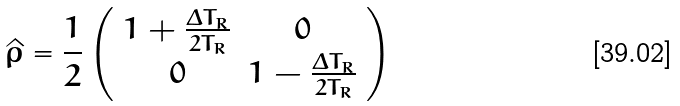<formula> <loc_0><loc_0><loc_500><loc_500>\hat { \rho } = \frac { 1 } { 2 } \left ( \begin{array} { c c } 1 + \frac { \Delta T _ { R } } { 2 T _ { R } } & 0 \\ 0 & 1 - \frac { \Delta T _ { R } } { 2 T _ { R } } \end{array} \right )</formula> 